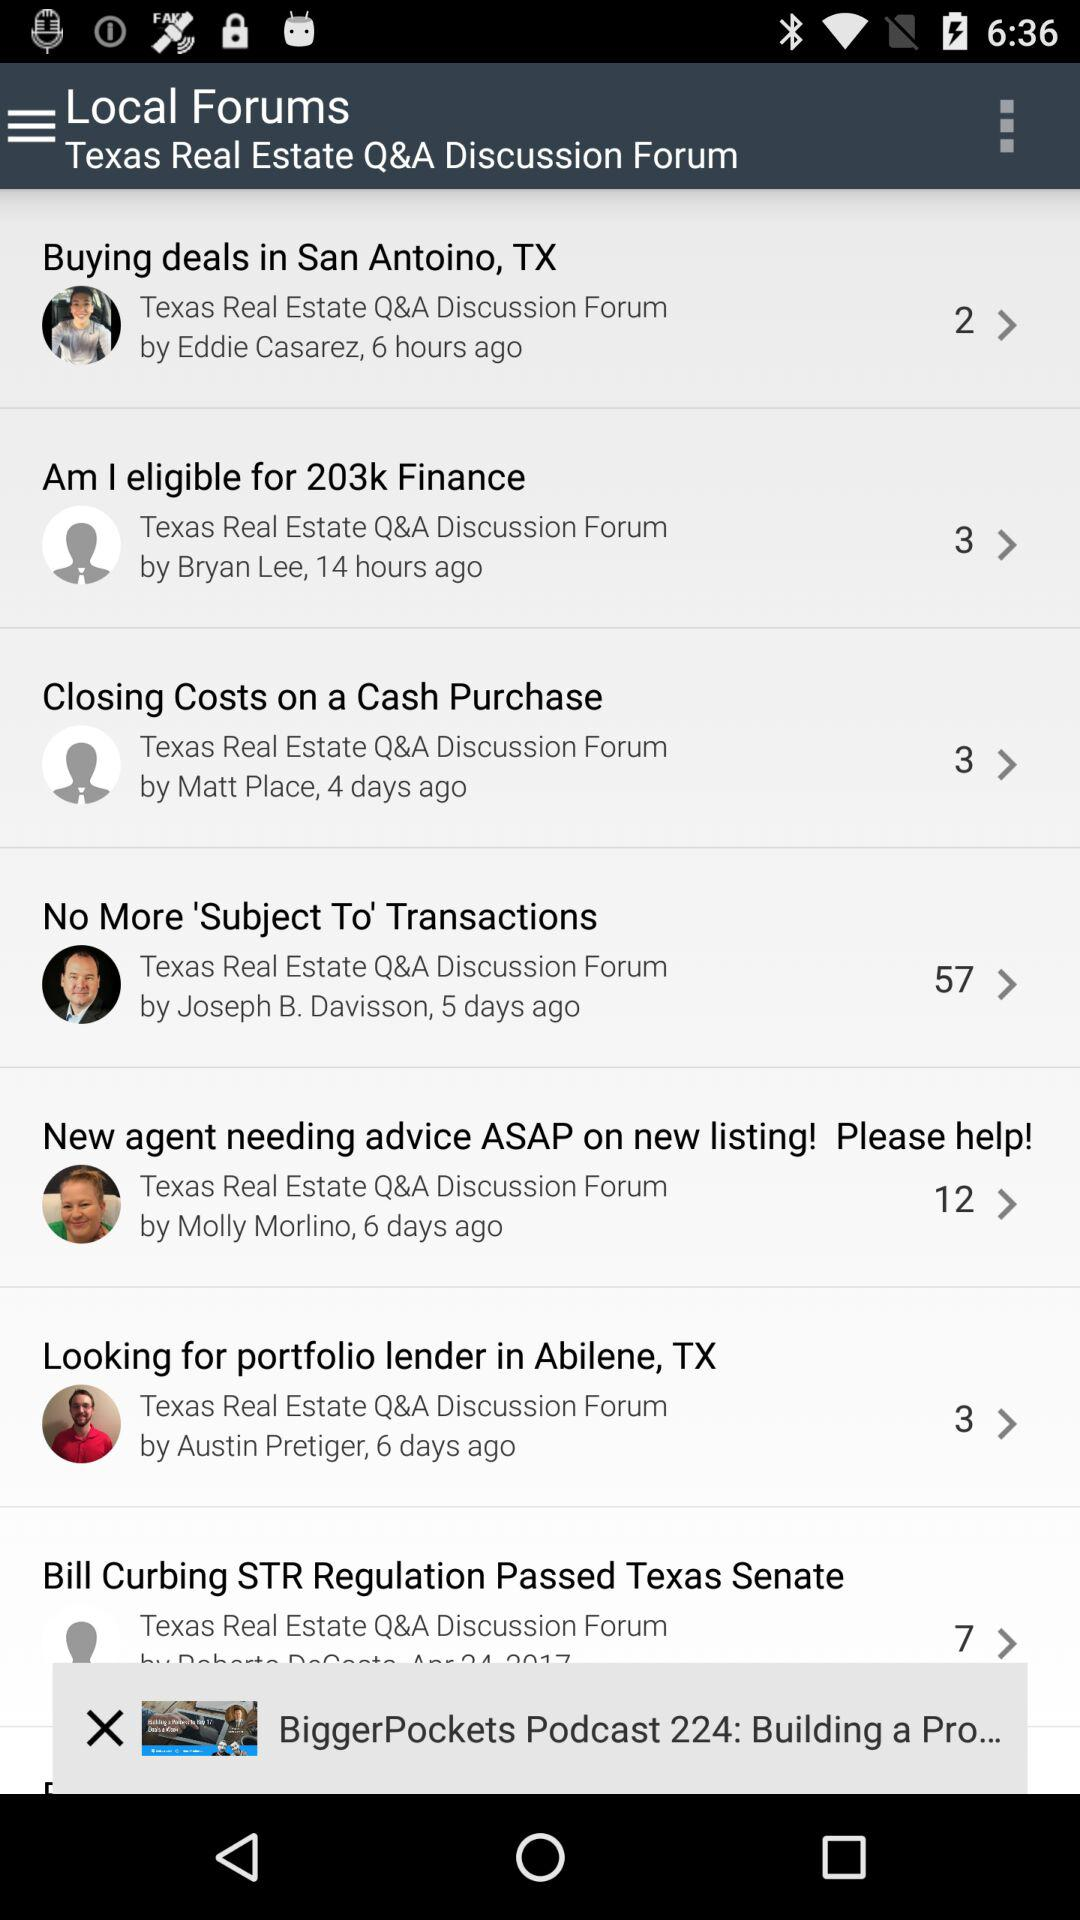How many days ago was "Closing Costs on a Cash Purchase" posted? The "Closing Costs on a Cash Purchase" was posted 4 days ago. 